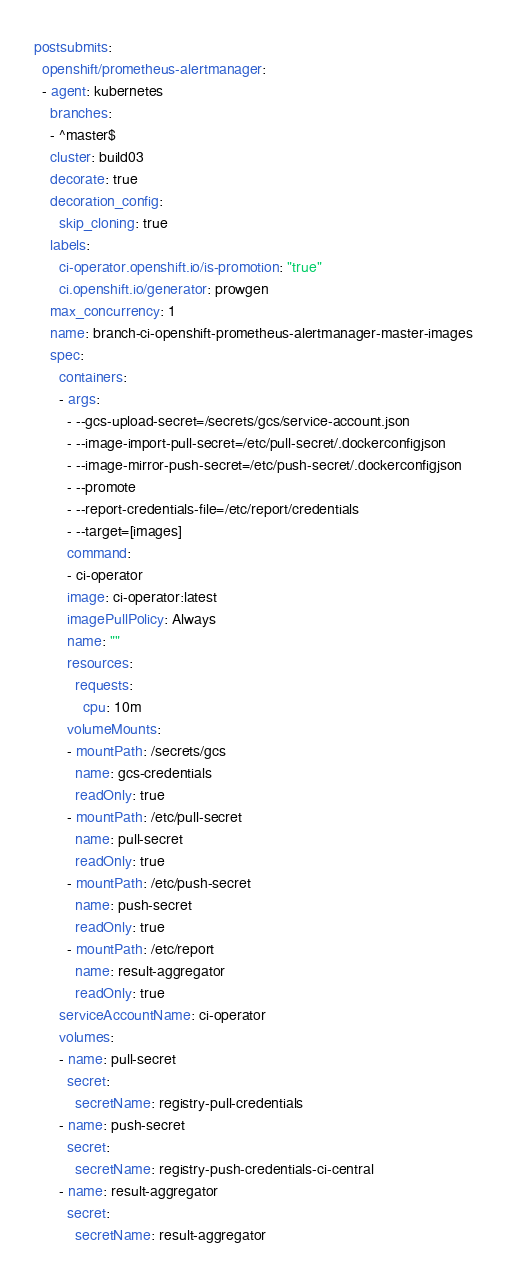Convert code to text. <code><loc_0><loc_0><loc_500><loc_500><_YAML_>postsubmits:
  openshift/prometheus-alertmanager:
  - agent: kubernetes
    branches:
    - ^master$
    cluster: build03
    decorate: true
    decoration_config:
      skip_cloning: true
    labels:
      ci-operator.openshift.io/is-promotion: "true"
      ci.openshift.io/generator: prowgen
    max_concurrency: 1
    name: branch-ci-openshift-prometheus-alertmanager-master-images
    spec:
      containers:
      - args:
        - --gcs-upload-secret=/secrets/gcs/service-account.json
        - --image-import-pull-secret=/etc/pull-secret/.dockerconfigjson
        - --image-mirror-push-secret=/etc/push-secret/.dockerconfigjson
        - --promote
        - --report-credentials-file=/etc/report/credentials
        - --target=[images]
        command:
        - ci-operator
        image: ci-operator:latest
        imagePullPolicy: Always
        name: ""
        resources:
          requests:
            cpu: 10m
        volumeMounts:
        - mountPath: /secrets/gcs
          name: gcs-credentials
          readOnly: true
        - mountPath: /etc/pull-secret
          name: pull-secret
          readOnly: true
        - mountPath: /etc/push-secret
          name: push-secret
          readOnly: true
        - mountPath: /etc/report
          name: result-aggregator
          readOnly: true
      serviceAccountName: ci-operator
      volumes:
      - name: pull-secret
        secret:
          secretName: registry-pull-credentials
      - name: push-secret
        secret:
          secretName: registry-push-credentials-ci-central
      - name: result-aggregator
        secret:
          secretName: result-aggregator
</code> 